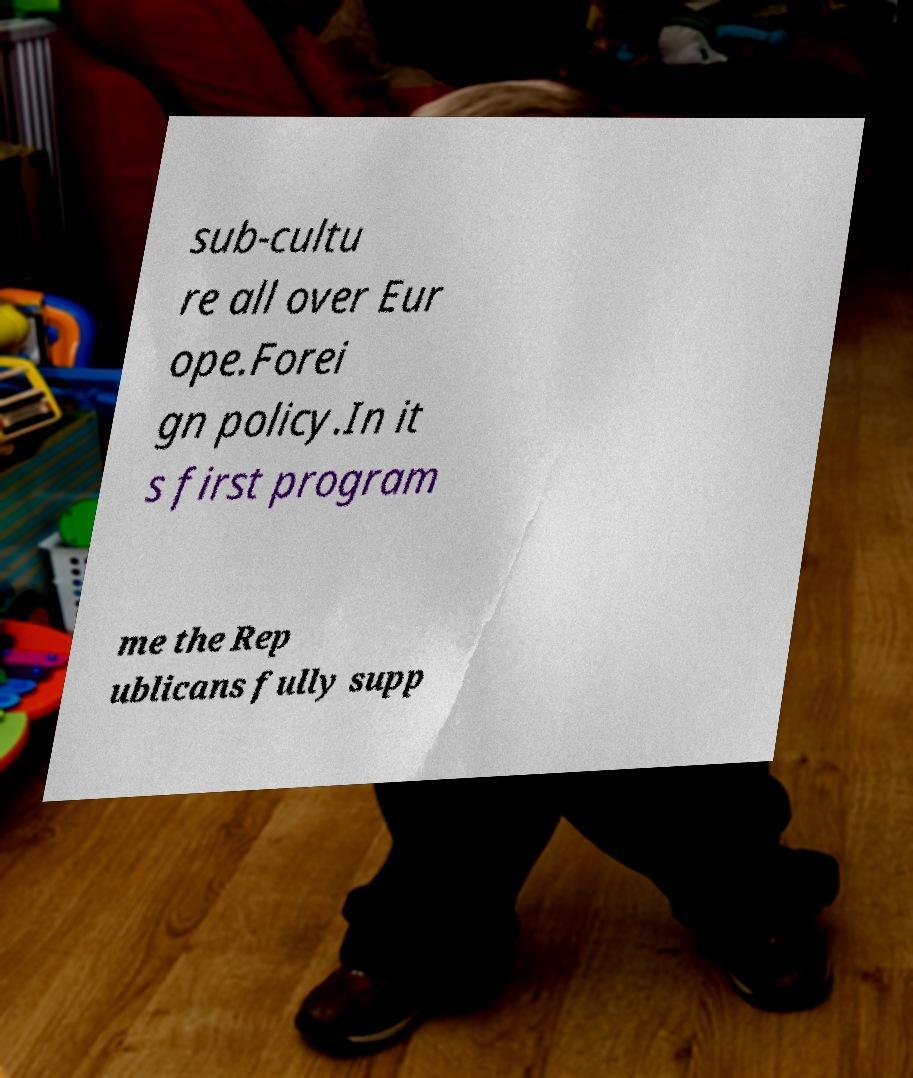Can you read and provide the text displayed in the image?This photo seems to have some interesting text. Can you extract and type it out for me? sub-cultu re all over Eur ope.Forei gn policy.In it s first program me the Rep ublicans fully supp 